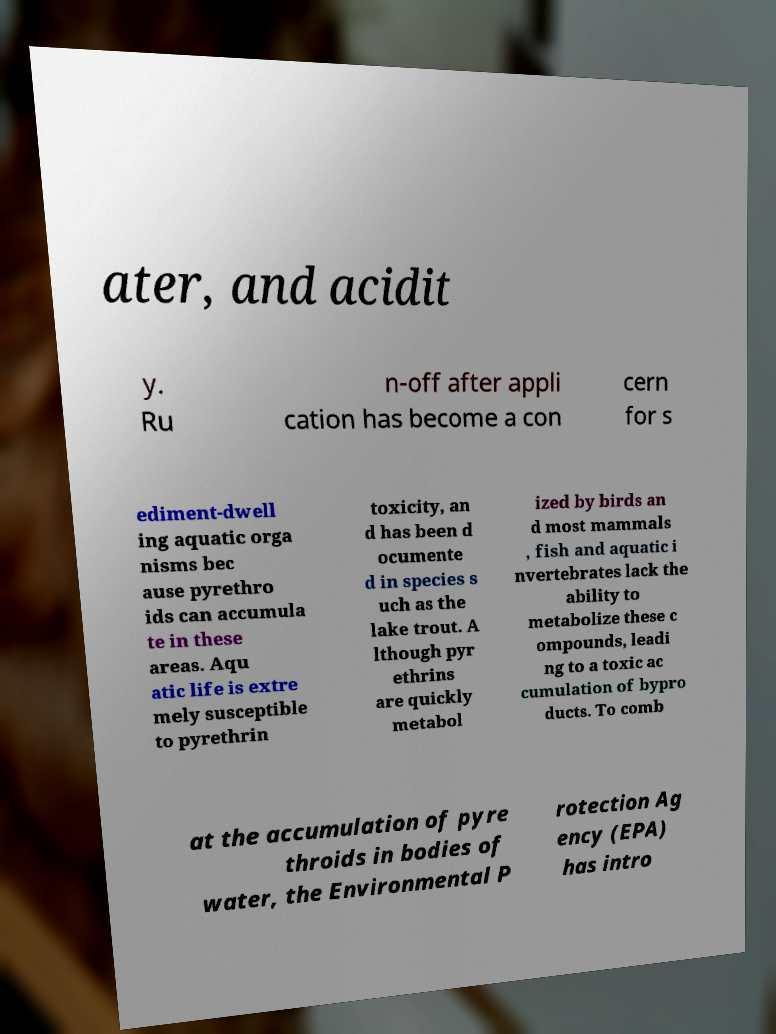I need the written content from this picture converted into text. Can you do that? ater, and acidit y. Ru n-off after appli cation has become a con cern for s ediment-dwell ing aquatic orga nisms bec ause pyrethro ids can accumula te in these areas. Aqu atic life is extre mely susceptible to pyrethrin toxicity, an d has been d ocumente d in species s uch as the lake trout. A lthough pyr ethrins are quickly metabol ized by birds an d most mammals , fish and aquatic i nvertebrates lack the ability to metabolize these c ompounds, leadi ng to a toxic ac cumulation of bypro ducts. To comb at the accumulation of pyre throids in bodies of water, the Environmental P rotection Ag ency (EPA) has intro 